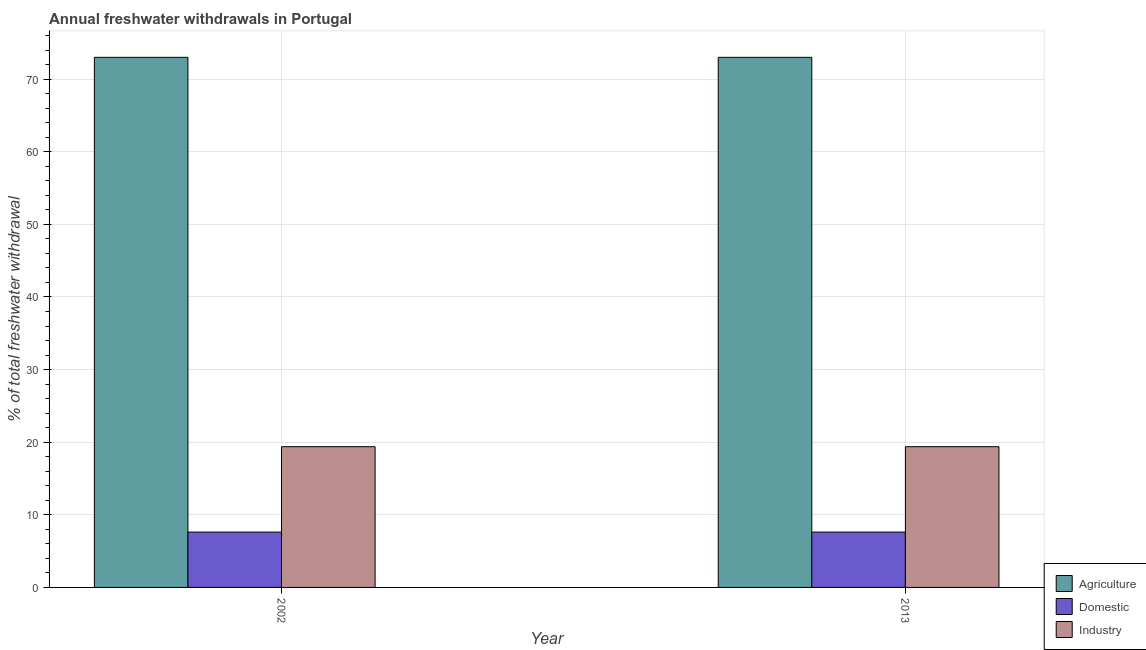How many different coloured bars are there?
Your response must be concise. 3. Are the number of bars per tick equal to the number of legend labels?
Your answer should be very brief. Yes. How many bars are there on the 2nd tick from the right?
Ensure brevity in your answer.  3. In how many cases, is the number of bars for a given year not equal to the number of legend labels?
Provide a short and direct response. 0. What is the percentage of freshwater withdrawal for agriculture in 2013?
Make the answer very short. 73. Across all years, what is the maximum percentage of freshwater withdrawal for industry?
Make the answer very short. 19.38. Across all years, what is the minimum percentage of freshwater withdrawal for industry?
Your answer should be compact. 19.38. In which year was the percentage of freshwater withdrawal for domestic purposes maximum?
Offer a very short reply. 2002. What is the total percentage of freshwater withdrawal for domestic purposes in the graph?
Offer a very short reply. 15.24. What is the difference between the percentage of freshwater withdrawal for agriculture in 2002 and that in 2013?
Your response must be concise. 0. What is the difference between the percentage of freshwater withdrawal for agriculture in 2013 and the percentage of freshwater withdrawal for domestic purposes in 2002?
Ensure brevity in your answer.  0. What is the average percentage of freshwater withdrawal for industry per year?
Ensure brevity in your answer.  19.38. Is the percentage of freshwater withdrawal for domestic purposes in 2002 less than that in 2013?
Provide a succinct answer. No. What does the 1st bar from the left in 2002 represents?
Your response must be concise. Agriculture. What does the 3rd bar from the right in 2013 represents?
Give a very brief answer. Agriculture. How many bars are there?
Keep it short and to the point. 6. How many years are there in the graph?
Keep it short and to the point. 2. What is the difference between two consecutive major ticks on the Y-axis?
Offer a terse response. 10. Are the values on the major ticks of Y-axis written in scientific E-notation?
Offer a terse response. No. What is the title of the graph?
Your answer should be compact. Annual freshwater withdrawals in Portugal. What is the label or title of the Y-axis?
Your answer should be very brief. % of total freshwater withdrawal. What is the % of total freshwater withdrawal in Agriculture in 2002?
Your answer should be compact. 73. What is the % of total freshwater withdrawal of Domestic in 2002?
Offer a very short reply. 7.62. What is the % of total freshwater withdrawal in Industry in 2002?
Keep it short and to the point. 19.38. What is the % of total freshwater withdrawal in Agriculture in 2013?
Offer a terse response. 73. What is the % of total freshwater withdrawal in Domestic in 2013?
Keep it short and to the point. 7.62. What is the % of total freshwater withdrawal of Industry in 2013?
Your answer should be compact. 19.38. Across all years, what is the maximum % of total freshwater withdrawal in Domestic?
Your answer should be very brief. 7.62. Across all years, what is the maximum % of total freshwater withdrawal of Industry?
Offer a very short reply. 19.38. Across all years, what is the minimum % of total freshwater withdrawal in Domestic?
Ensure brevity in your answer.  7.62. Across all years, what is the minimum % of total freshwater withdrawal of Industry?
Ensure brevity in your answer.  19.38. What is the total % of total freshwater withdrawal of Agriculture in the graph?
Offer a terse response. 146. What is the total % of total freshwater withdrawal in Domestic in the graph?
Your answer should be compact. 15.24. What is the total % of total freshwater withdrawal of Industry in the graph?
Give a very brief answer. 38.76. What is the difference between the % of total freshwater withdrawal of Agriculture in 2002 and that in 2013?
Your response must be concise. 0. What is the difference between the % of total freshwater withdrawal of Industry in 2002 and that in 2013?
Give a very brief answer. 0. What is the difference between the % of total freshwater withdrawal in Agriculture in 2002 and the % of total freshwater withdrawal in Domestic in 2013?
Offer a terse response. 65.38. What is the difference between the % of total freshwater withdrawal of Agriculture in 2002 and the % of total freshwater withdrawal of Industry in 2013?
Make the answer very short. 53.62. What is the difference between the % of total freshwater withdrawal of Domestic in 2002 and the % of total freshwater withdrawal of Industry in 2013?
Ensure brevity in your answer.  -11.76. What is the average % of total freshwater withdrawal of Domestic per year?
Give a very brief answer. 7.62. What is the average % of total freshwater withdrawal of Industry per year?
Your response must be concise. 19.38. In the year 2002, what is the difference between the % of total freshwater withdrawal in Agriculture and % of total freshwater withdrawal in Domestic?
Provide a succinct answer. 65.38. In the year 2002, what is the difference between the % of total freshwater withdrawal of Agriculture and % of total freshwater withdrawal of Industry?
Provide a succinct answer. 53.62. In the year 2002, what is the difference between the % of total freshwater withdrawal of Domestic and % of total freshwater withdrawal of Industry?
Make the answer very short. -11.76. In the year 2013, what is the difference between the % of total freshwater withdrawal in Agriculture and % of total freshwater withdrawal in Domestic?
Your response must be concise. 65.38. In the year 2013, what is the difference between the % of total freshwater withdrawal in Agriculture and % of total freshwater withdrawal in Industry?
Offer a very short reply. 53.62. In the year 2013, what is the difference between the % of total freshwater withdrawal in Domestic and % of total freshwater withdrawal in Industry?
Make the answer very short. -11.76. What is the ratio of the % of total freshwater withdrawal of Agriculture in 2002 to that in 2013?
Make the answer very short. 1. What is the ratio of the % of total freshwater withdrawal of Domestic in 2002 to that in 2013?
Offer a terse response. 1. What is the difference between the highest and the second highest % of total freshwater withdrawal in Domestic?
Make the answer very short. 0. What is the difference between the highest and the second highest % of total freshwater withdrawal in Industry?
Provide a short and direct response. 0. What is the difference between the highest and the lowest % of total freshwater withdrawal in Industry?
Provide a succinct answer. 0. 